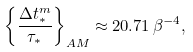<formula> <loc_0><loc_0><loc_500><loc_500>\left \{ \frac { \Delta t _ { * } ^ { m } } { \tau _ { * } } \right \} _ { A M } \approx 2 0 . 7 1 \, \beta ^ { - 4 } ,</formula> 